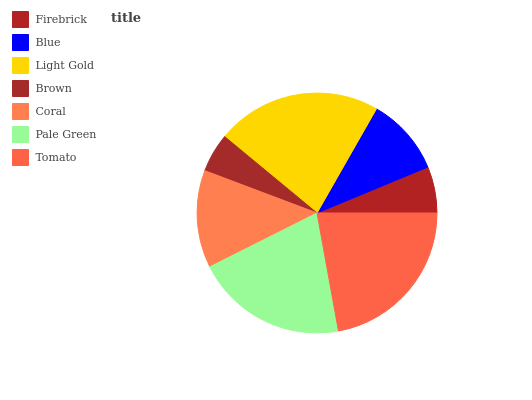Is Brown the minimum?
Answer yes or no. Yes. Is Light Gold the maximum?
Answer yes or no. Yes. Is Blue the minimum?
Answer yes or no. No. Is Blue the maximum?
Answer yes or no. No. Is Blue greater than Firebrick?
Answer yes or no. Yes. Is Firebrick less than Blue?
Answer yes or no. Yes. Is Firebrick greater than Blue?
Answer yes or no. No. Is Blue less than Firebrick?
Answer yes or no. No. Is Coral the high median?
Answer yes or no. Yes. Is Coral the low median?
Answer yes or no. Yes. Is Tomato the high median?
Answer yes or no. No. Is Blue the low median?
Answer yes or no. No. 